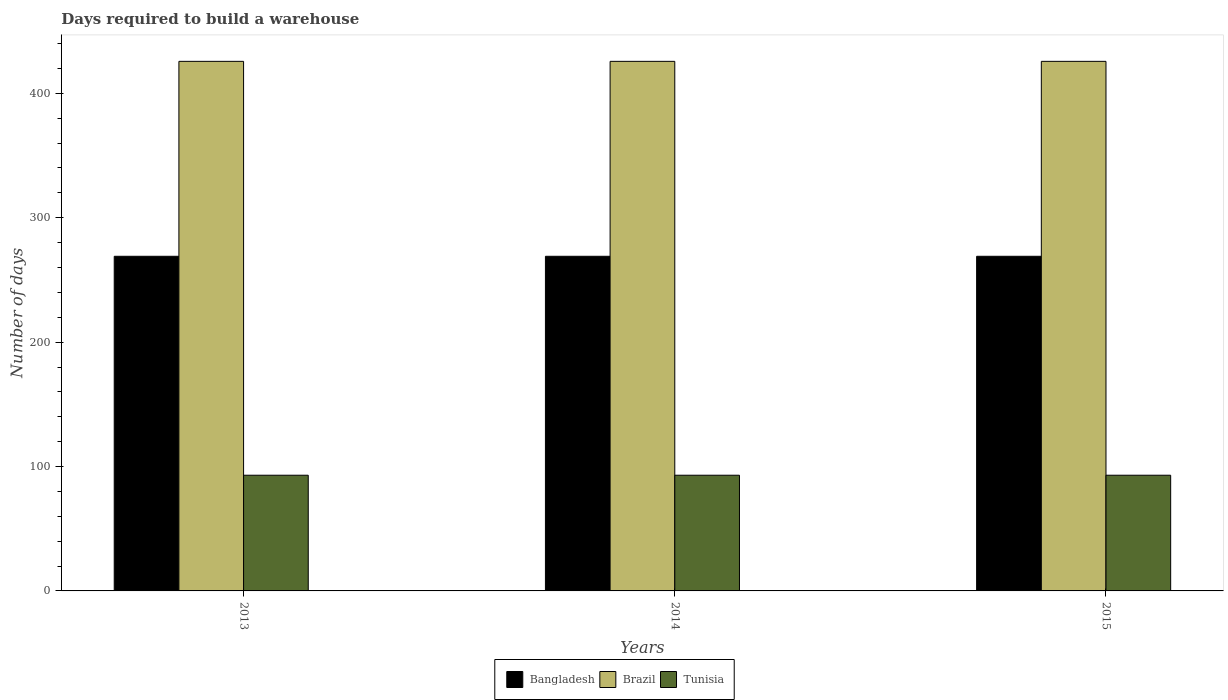How many bars are there on the 1st tick from the left?
Offer a terse response. 3. How many bars are there on the 2nd tick from the right?
Make the answer very short. 3. What is the label of the 1st group of bars from the left?
Your answer should be compact. 2013. What is the days required to build a warehouse in in Brazil in 2015?
Your answer should be very brief. 425.7. Across all years, what is the maximum days required to build a warehouse in in Brazil?
Your answer should be compact. 425.7. Across all years, what is the minimum days required to build a warehouse in in Tunisia?
Your response must be concise. 93. In which year was the days required to build a warehouse in in Brazil maximum?
Keep it short and to the point. 2013. In which year was the days required to build a warehouse in in Bangladesh minimum?
Give a very brief answer. 2013. What is the total days required to build a warehouse in in Bangladesh in the graph?
Provide a succinct answer. 807. What is the difference between the days required to build a warehouse in in Tunisia in 2015 and the days required to build a warehouse in in Bangladesh in 2014?
Ensure brevity in your answer.  -176. What is the average days required to build a warehouse in in Bangladesh per year?
Your response must be concise. 269. In the year 2014, what is the difference between the days required to build a warehouse in in Tunisia and days required to build a warehouse in in Brazil?
Your answer should be compact. -332.7. Is the difference between the days required to build a warehouse in in Tunisia in 2014 and 2015 greater than the difference between the days required to build a warehouse in in Brazil in 2014 and 2015?
Your answer should be very brief. No. What does the 3rd bar from the left in 2014 represents?
Provide a succinct answer. Tunisia. How many bars are there?
Your answer should be very brief. 9. Are all the bars in the graph horizontal?
Your answer should be compact. No. What is the difference between two consecutive major ticks on the Y-axis?
Your response must be concise. 100. Does the graph contain any zero values?
Give a very brief answer. No. Does the graph contain grids?
Offer a very short reply. No. How are the legend labels stacked?
Give a very brief answer. Horizontal. What is the title of the graph?
Make the answer very short. Days required to build a warehouse. Does "Burkina Faso" appear as one of the legend labels in the graph?
Your answer should be very brief. No. What is the label or title of the Y-axis?
Your answer should be very brief. Number of days. What is the Number of days of Bangladesh in 2013?
Your answer should be very brief. 269. What is the Number of days of Brazil in 2013?
Make the answer very short. 425.7. What is the Number of days in Tunisia in 2013?
Provide a succinct answer. 93. What is the Number of days in Bangladesh in 2014?
Provide a succinct answer. 269. What is the Number of days of Brazil in 2014?
Offer a terse response. 425.7. What is the Number of days in Tunisia in 2014?
Give a very brief answer. 93. What is the Number of days of Bangladesh in 2015?
Ensure brevity in your answer.  269. What is the Number of days in Brazil in 2015?
Provide a short and direct response. 425.7. What is the Number of days in Tunisia in 2015?
Offer a terse response. 93. Across all years, what is the maximum Number of days in Bangladesh?
Provide a succinct answer. 269. Across all years, what is the maximum Number of days in Brazil?
Your answer should be very brief. 425.7. Across all years, what is the maximum Number of days in Tunisia?
Make the answer very short. 93. Across all years, what is the minimum Number of days in Bangladesh?
Provide a short and direct response. 269. Across all years, what is the minimum Number of days of Brazil?
Keep it short and to the point. 425.7. Across all years, what is the minimum Number of days in Tunisia?
Offer a very short reply. 93. What is the total Number of days of Bangladesh in the graph?
Your answer should be very brief. 807. What is the total Number of days of Brazil in the graph?
Ensure brevity in your answer.  1277.1. What is the total Number of days of Tunisia in the graph?
Keep it short and to the point. 279. What is the difference between the Number of days in Bangladesh in 2013 and that in 2014?
Ensure brevity in your answer.  0. What is the difference between the Number of days of Tunisia in 2013 and that in 2015?
Provide a short and direct response. 0. What is the difference between the Number of days in Brazil in 2014 and that in 2015?
Provide a short and direct response. 0. What is the difference between the Number of days of Bangladesh in 2013 and the Number of days of Brazil in 2014?
Make the answer very short. -156.7. What is the difference between the Number of days of Bangladesh in 2013 and the Number of days of Tunisia in 2014?
Make the answer very short. 176. What is the difference between the Number of days in Brazil in 2013 and the Number of days in Tunisia in 2014?
Ensure brevity in your answer.  332.7. What is the difference between the Number of days in Bangladesh in 2013 and the Number of days in Brazil in 2015?
Give a very brief answer. -156.7. What is the difference between the Number of days in Bangladesh in 2013 and the Number of days in Tunisia in 2015?
Offer a terse response. 176. What is the difference between the Number of days in Brazil in 2013 and the Number of days in Tunisia in 2015?
Give a very brief answer. 332.7. What is the difference between the Number of days in Bangladesh in 2014 and the Number of days in Brazil in 2015?
Ensure brevity in your answer.  -156.7. What is the difference between the Number of days of Bangladesh in 2014 and the Number of days of Tunisia in 2015?
Your answer should be very brief. 176. What is the difference between the Number of days of Brazil in 2014 and the Number of days of Tunisia in 2015?
Give a very brief answer. 332.7. What is the average Number of days of Bangladesh per year?
Your response must be concise. 269. What is the average Number of days of Brazil per year?
Give a very brief answer. 425.7. What is the average Number of days in Tunisia per year?
Offer a terse response. 93. In the year 2013, what is the difference between the Number of days in Bangladesh and Number of days in Brazil?
Keep it short and to the point. -156.7. In the year 2013, what is the difference between the Number of days in Bangladesh and Number of days in Tunisia?
Provide a short and direct response. 176. In the year 2013, what is the difference between the Number of days of Brazil and Number of days of Tunisia?
Offer a terse response. 332.7. In the year 2014, what is the difference between the Number of days of Bangladesh and Number of days of Brazil?
Keep it short and to the point. -156.7. In the year 2014, what is the difference between the Number of days of Bangladesh and Number of days of Tunisia?
Keep it short and to the point. 176. In the year 2014, what is the difference between the Number of days in Brazil and Number of days in Tunisia?
Make the answer very short. 332.7. In the year 2015, what is the difference between the Number of days in Bangladesh and Number of days in Brazil?
Make the answer very short. -156.7. In the year 2015, what is the difference between the Number of days of Bangladesh and Number of days of Tunisia?
Your response must be concise. 176. In the year 2015, what is the difference between the Number of days of Brazil and Number of days of Tunisia?
Make the answer very short. 332.7. What is the ratio of the Number of days in Bangladesh in 2013 to that in 2014?
Give a very brief answer. 1. What is the ratio of the Number of days in Brazil in 2013 to that in 2014?
Keep it short and to the point. 1. What is the ratio of the Number of days in Tunisia in 2013 to that in 2014?
Offer a terse response. 1. What is the ratio of the Number of days in Brazil in 2013 to that in 2015?
Keep it short and to the point. 1. What is the ratio of the Number of days in Bangladesh in 2014 to that in 2015?
Give a very brief answer. 1. What is the difference between the highest and the second highest Number of days of Brazil?
Ensure brevity in your answer.  0. 